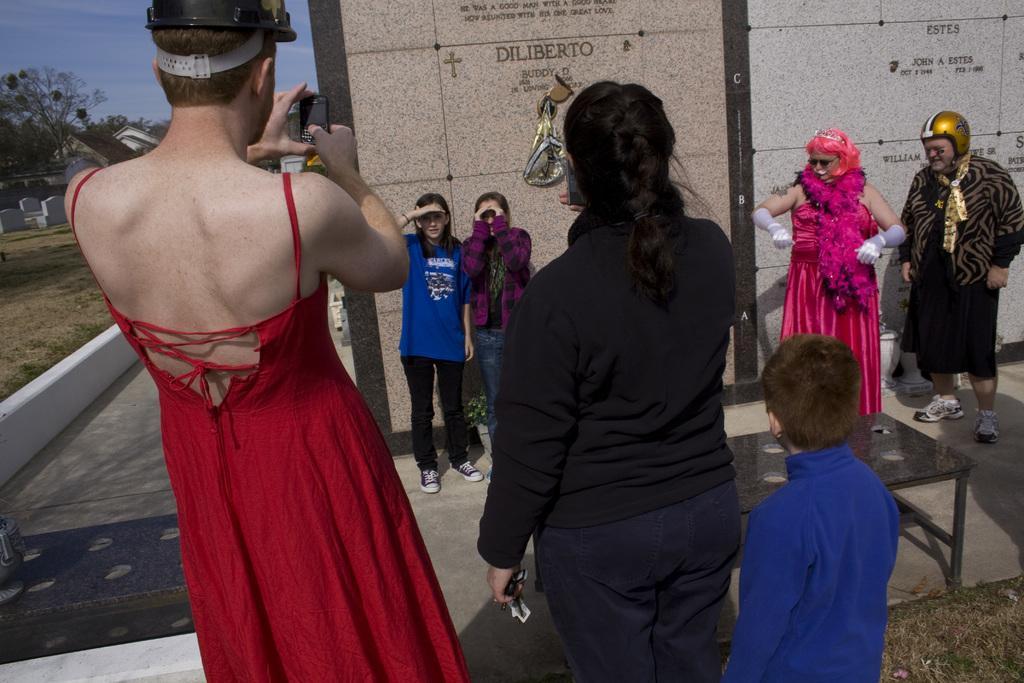Can you describe this image briefly? In this image I can see the group of people with different color dresses. I can see two people wearing the helmets and one person holding the mobile. There is a table in-front of two people. In the back I can see the wall and something is written on it. To the left I cans many trees and the sky. 